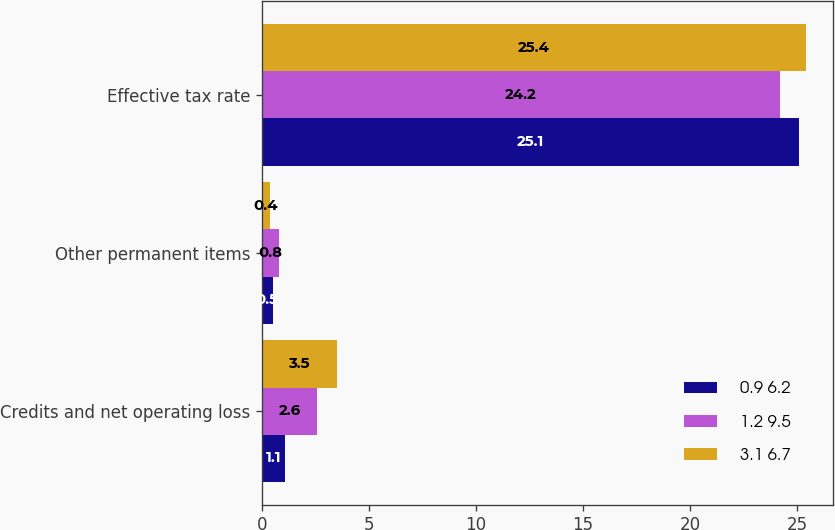<chart> <loc_0><loc_0><loc_500><loc_500><stacked_bar_chart><ecel><fcel>Credits and net operating loss<fcel>Other permanent items<fcel>Effective tax rate<nl><fcel>0.9 6.2<fcel>1.1<fcel>0.5<fcel>25.1<nl><fcel>1.2 9.5<fcel>2.6<fcel>0.8<fcel>24.2<nl><fcel>3.1 6.7<fcel>3.5<fcel>0.4<fcel>25.4<nl></chart> 